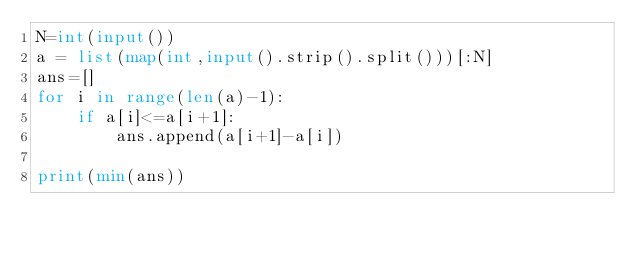Convert code to text. <code><loc_0><loc_0><loc_500><loc_500><_Python_>N=int(input())
a = list(map(int,input().strip().split()))[:N]
ans=[]
for i in range(len(a)-1):
    if a[i]<=a[i+1]:
        ans.append(a[i+1]-a[i])

print(min(ans))
        
</code> 